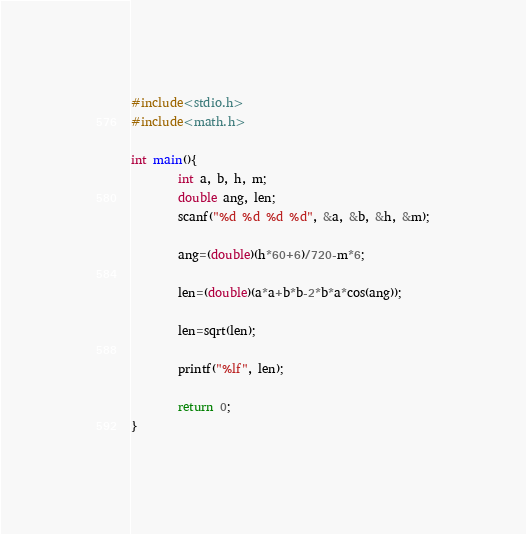Convert code to text. <code><loc_0><loc_0><loc_500><loc_500><_C_>#include<stdio.h>
#include<math.h>

int main(){
        int a, b, h, m;
        double ang, len;
        scanf("%d %d %d %d", &a, &b, &h, &m);

        ang=(double)(h*60+6)/720-m*6;

        len=(double)(a*a+b*b-2*b*a*cos(ang));

        len=sqrt(len);

        printf("%lf", len);

        return 0;
}

</code> 